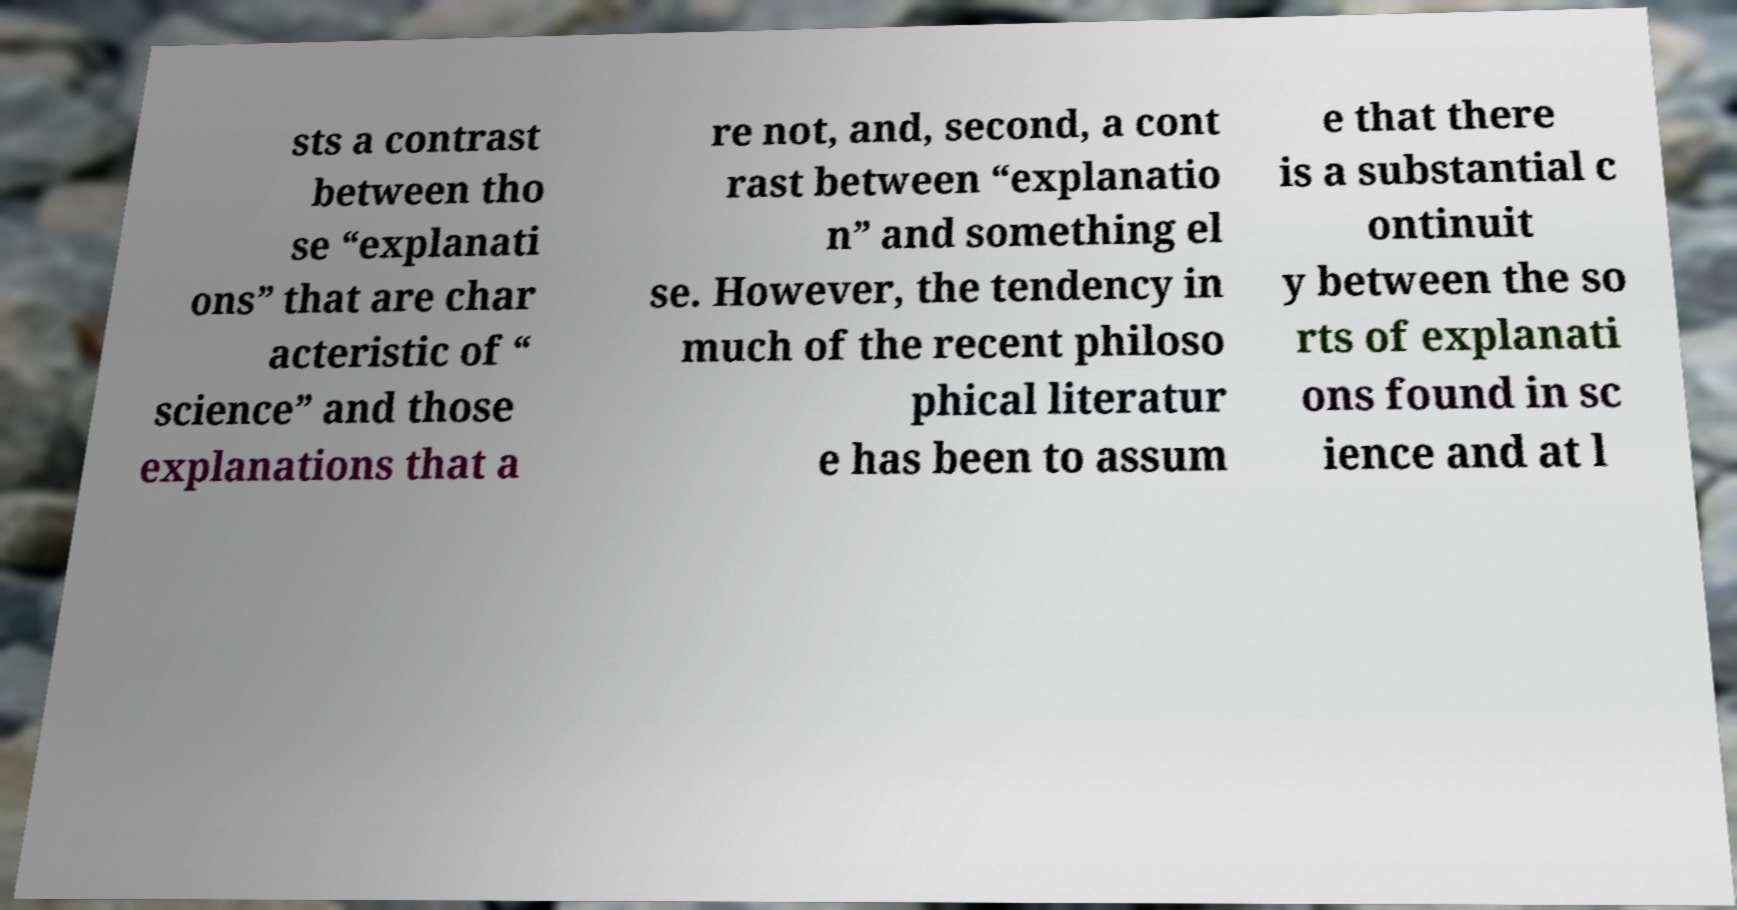Could you assist in decoding the text presented in this image and type it out clearly? sts a contrast between tho se “explanati ons” that are char acteristic of “ science” and those explanations that a re not, and, second, a cont rast between “explanatio n” and something el se. However, the tendency in much of the recent philoso phical literatur e has been to assum e that there is a substantial c ontinuit y between the so rts of explanati ons found in sc ience and at l 